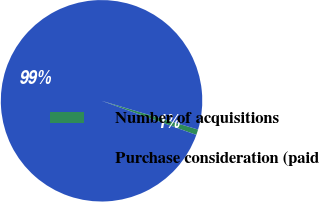<chart> <loc_0><loc_0><loc_500><loc_500><pie_chart><fcel>Number of acquisitions<fcel>Purchase consideration (paid<nl><fcel>0.89%<fcel>99.11%<nl></chart> 